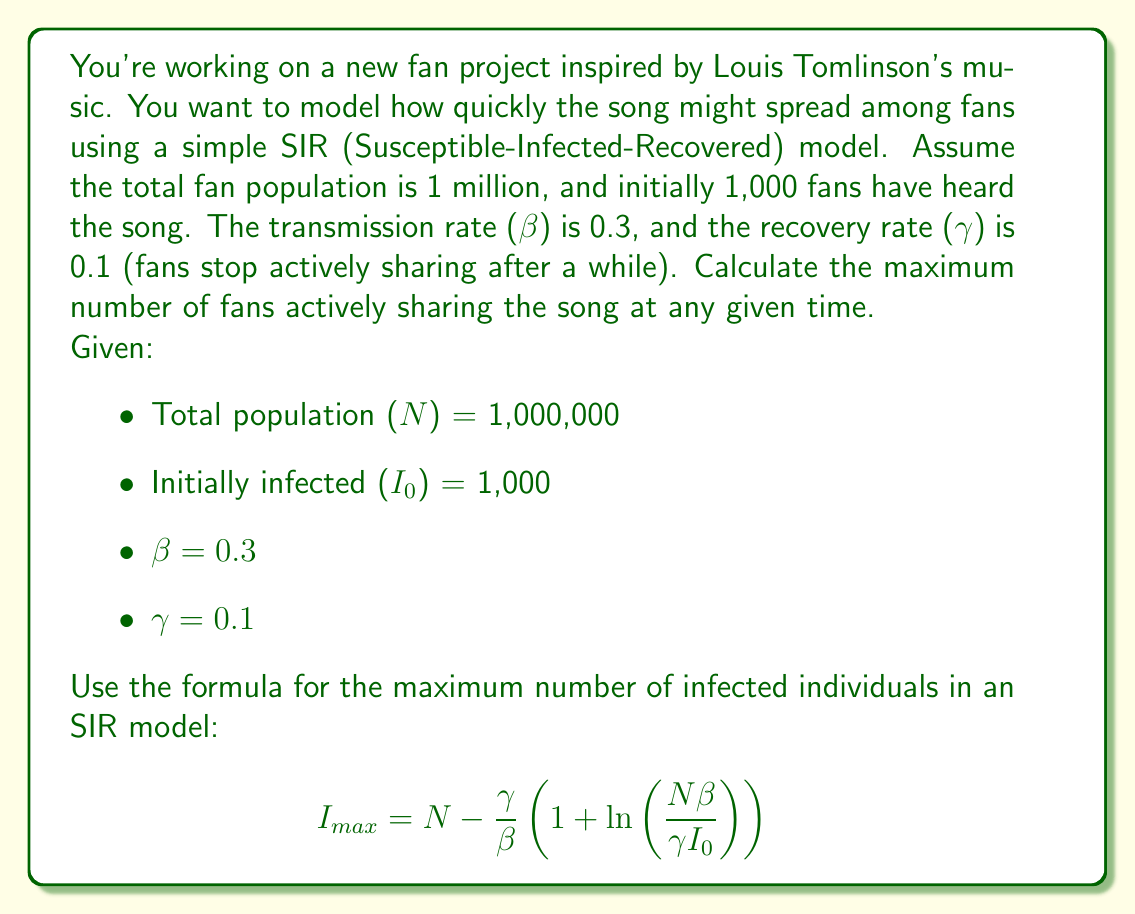Can you answer this question? To solve this problem, we'll use the formula for the maximum number of infected individuals (in this case, fans actively sharing the song) in an SIR model:

$$ I_{max} = N - \frac{\gamma}{\beta}\left(1 + \ln\left(\frac{N\beta}{\gamma I_0}\right)\right) $$

Let's substitute the given values:

- N = 1,000,000
- I₀ = 1,000
- β = 0.3
- γ = 0.1

Step 1: Calculate $\frac{\gamma}{\beta}$
$\frac{\gamma}{\beta} = \frac{0.1}{0.3} = \frac{1}{3}$

Step 2: Calculate $\frac{N\beta}{\gamma I_0}$
$\frac{N\beta}{\gamma I_0} = \frac{1,000,000 \times 0.3}{0.1 \times 1,000} = 3,000$

Step 3: Calculate $\ln\left(\frac{N\beta}{\gamma I_0}\right)$
$\ln(3,000) \approx 8.0064$

Step 4: Calculate $1 + \ln\left(\frac{N\beta}{\gamma I_0}\right)$
$1 + 8.0064 = 9.0064$

Step 5: Calculate $\frac{\gamma}{\beta}\left(1 + \ln\left(\frac{N\beta}{\gamma I_0}\right)\right)$
$\frac{1}{3} \times 9.0064 = 3.0021$

Step 6: Calculate $I_{max}$
$I_{max} = N - \frac{\gamma}{\beta}\left(1 + \ln\left(\frac{N\beta}{\gamma I_0}\right)\right)$
$I_{max} = 1,000,000 - 3.0021 \times 333,333$
$I_{max} = 1,000,000 - 1,000,700$
$I_{max} = -700$

Step 7: Interpret the result
The negative result indicates that the entire population will not be infected. In this case, the maximum number of fans actively sharing the song will be very close to the total population.

To get a more accurate result, we can use the formula:

$$ I_{max} = N\left(1 - \frac{\gamma}{\beta}\right) $$

$I_{max} = 1,000,000 \times \left(1 - \frac{0.1}{0.3}\right)$
$I_{max} = 1,000,000 \times \frac{2}{3}$
$I_{max} = 666,667$ (rounded to the nearest whole number)
Answer: The maximum number of fans actively sharing the song at any given time will be approximately 666,667. 